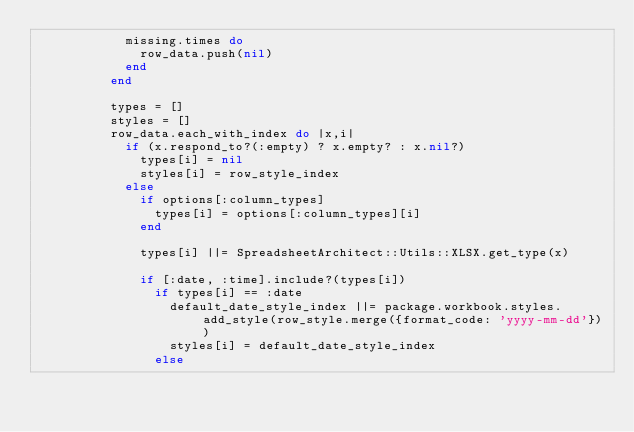Convert code to text. <code><loc_0><loc_0><loc_500><loc_500><_Ruby_>            missing.times do
              row_data.push(nil)
            end
          end

          types = []
          styles = []
          row_data.each_with_index do |x,i|
            if (x.respond_to?(:empty) ? x.empty? : x.nil?)
              types[i] = nil
              styles[i] = row_style_index
            else
              if options[:column_types]
                types[i] = options[:column_types][i]
              end

              types[i] ||= SpreadsheetArchitect::Utils::XLSX.get_type(x)

              if [:date, :time].include?(types[i])
                if types[i] == :date
                  default_date_style_index ||= package.workbook.styles.add_style(row_style.merge({format_code: 'yyyy-mm-dd'}))
                  styles[i] = default_date_style_index
                else</code> 